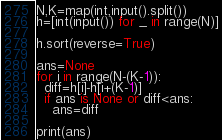Convert code to text. <code><loc_0><loc_0><loc_500><loc_500><_Python_>N,K=map(int,input().split())
h=[int(input()) for _ in range(N)]

h.sort(reverse=True)

ans=None
for i in range(N-(K-1)):
  diff=h[i]-h[i+(K-1)]
  if ans is None or diff<ans:
    ans=diff
    
print(ans)</code> 